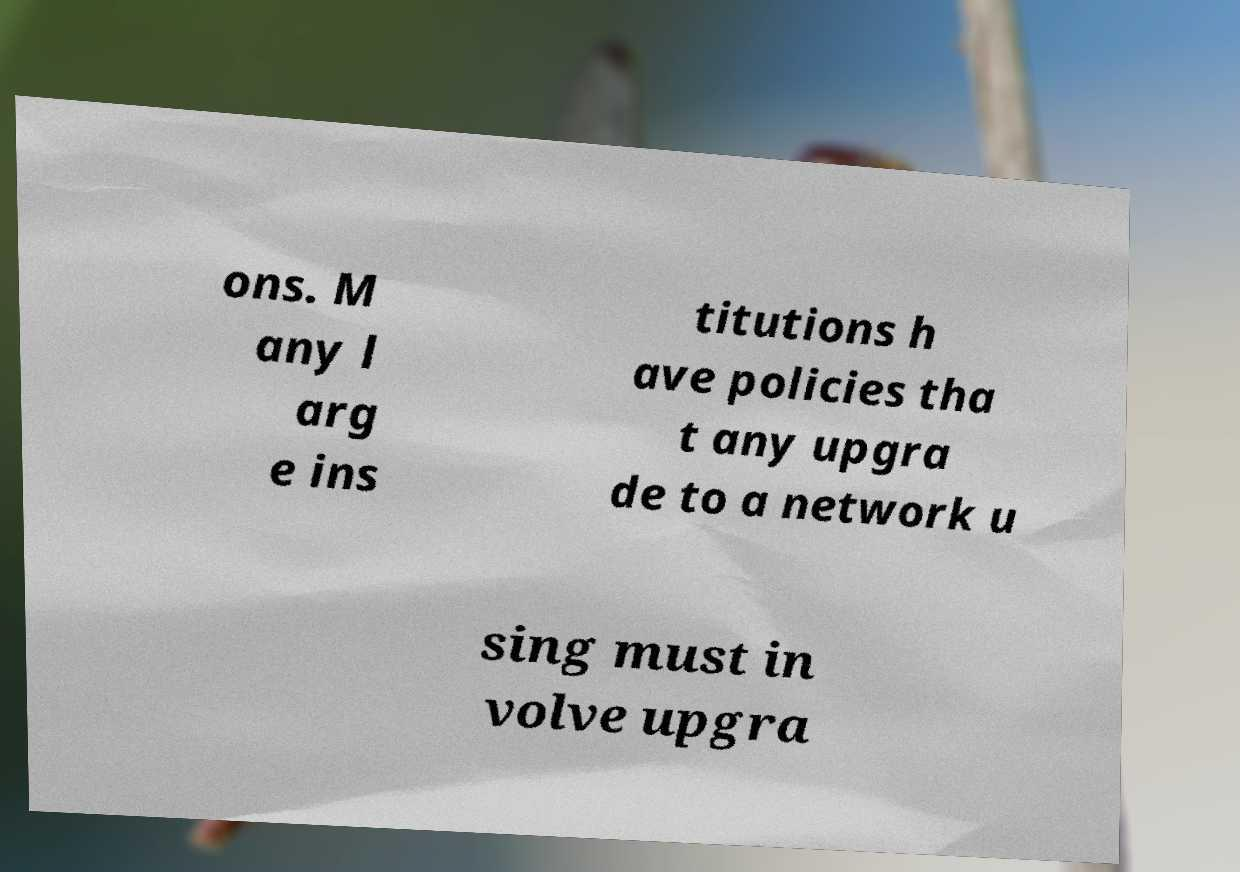Can you read and provide the text displayed in the image?This photo seems to have some interesting text. Can you extract and type it out for me? ons. M any l arg e ins titutions h ave policies tha t any upgra de to a network u sing must in volve upgra 